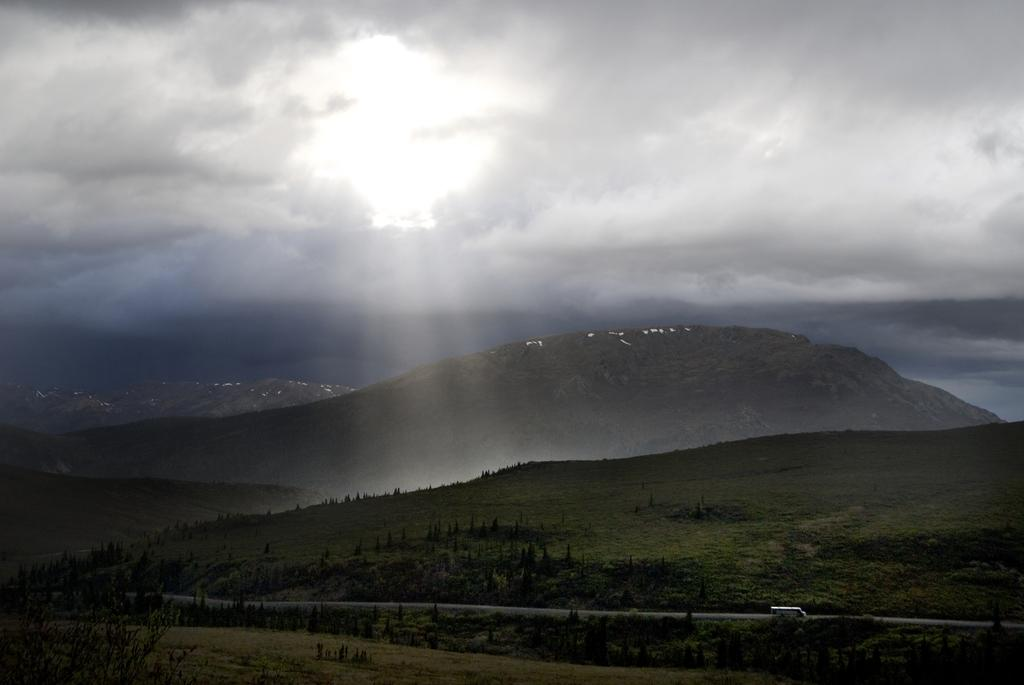What can be seen in the foreground of the image? In the foreground of the image, there are hills, trees, a road, a vehicle, and grass. What type of vegetation is present in the foreground? Trees and grass are present in the foreground of the image. What is the condition of the sky in the image? The sky is visible at the top of the image, with clouds present. What can be seen in the center of the image? Sun rays are present in the center of the image. What type of record can be seen spinning on the vehicle's dashboard in the image? There is no record present in the image; it features a vehicle on a road with hills, trees, and grass in the foreground. What type of ring is visible on the trees in the image? There are no rings visible on the trees in the image; it only shows trees, hills, a road, a vehicle, and grass in the foreground. 